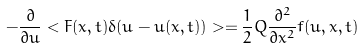Convert formula to latex. <formula><loc_0><loc_0><loc_500><loc_500>- \frac { \partial } { \partial u } < F ( x , t ) \delta ( u - u ( x , t ) ) > = \frac { 1 } { 2 } Q \frac { \partial ^ { 2 } } { \partial x ^ { 2 } } f ( u , x , t )</formula> 